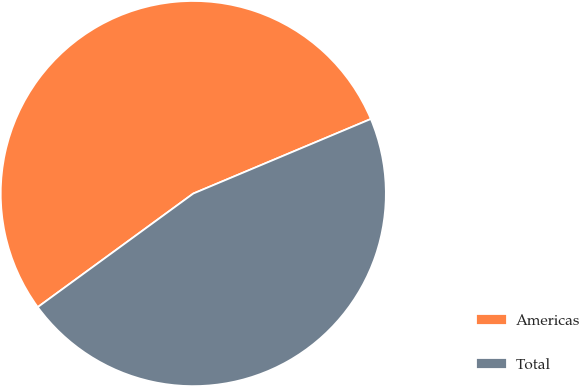Convert chart. <chart><loc_0><loc_0><loc_500><loc_500><pie_chart><fcel>Americas<fcel>Total<nl><fcel>53.71%<fcel>46.29%<nl></chart> 